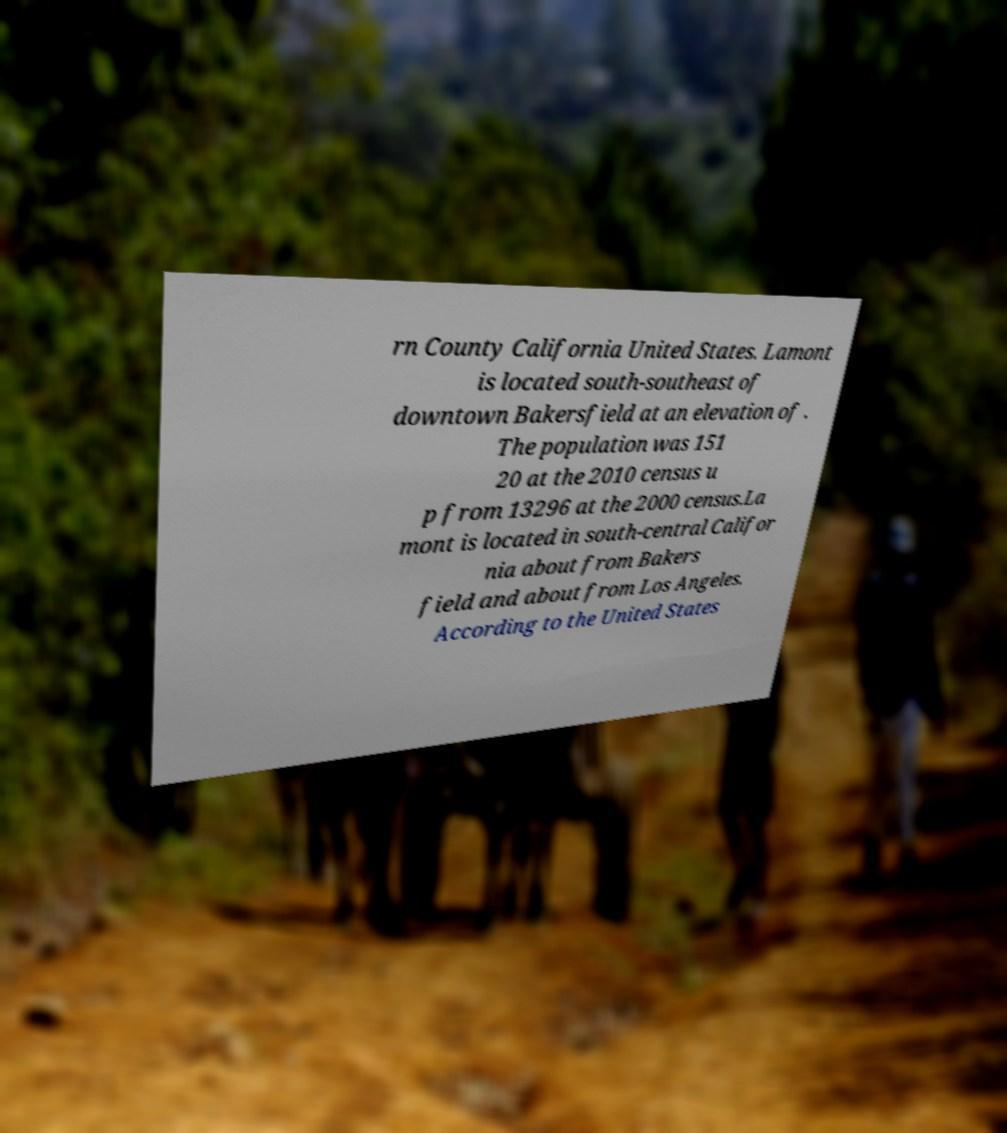Can you read and provide the text displayed in the image?This photo seems to have some interesting text. Can you extract and type it out for me? rn County California United States. Lamont is located south-southeast of downtown Bakersfield at an elevation of . The population was 151 20 at the 2010 census u p from 13296 at the 2000 census.La mont is located in south-central Califor nia about from Bakers field and about from Los Angeles. According to the United States 